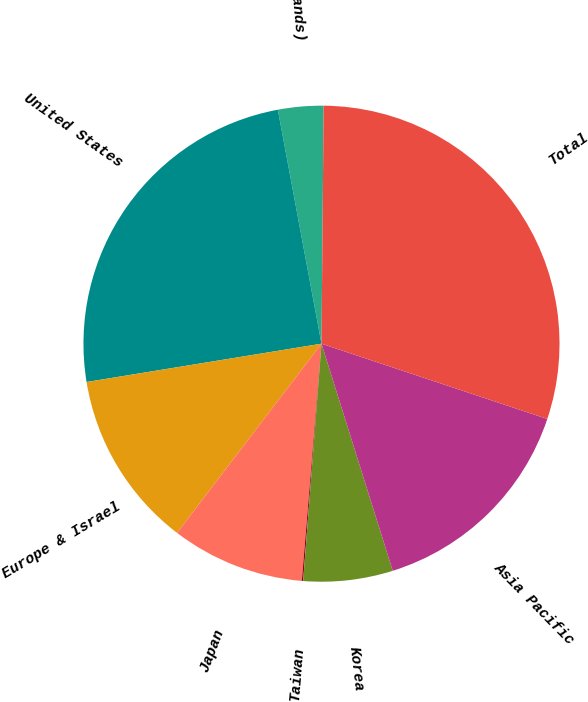<chart> <loc_0><loc_0><loc_500><loc_500><pie_chart><fcel>(In thousands)<fcel>United States<fcel>Europe & Israel<fcel>Japan<fcel>Taiwan<fcel>Korea<fcel>Asia Pacific<fcel>Total<nl><fcel>3.08%<fcel>24.64%<fcel>12.05%<fcel>9.06%<fcel>0.09%<fcel>6.07%<fcel>15.04%<fcel>29.98%<nl></chart> 